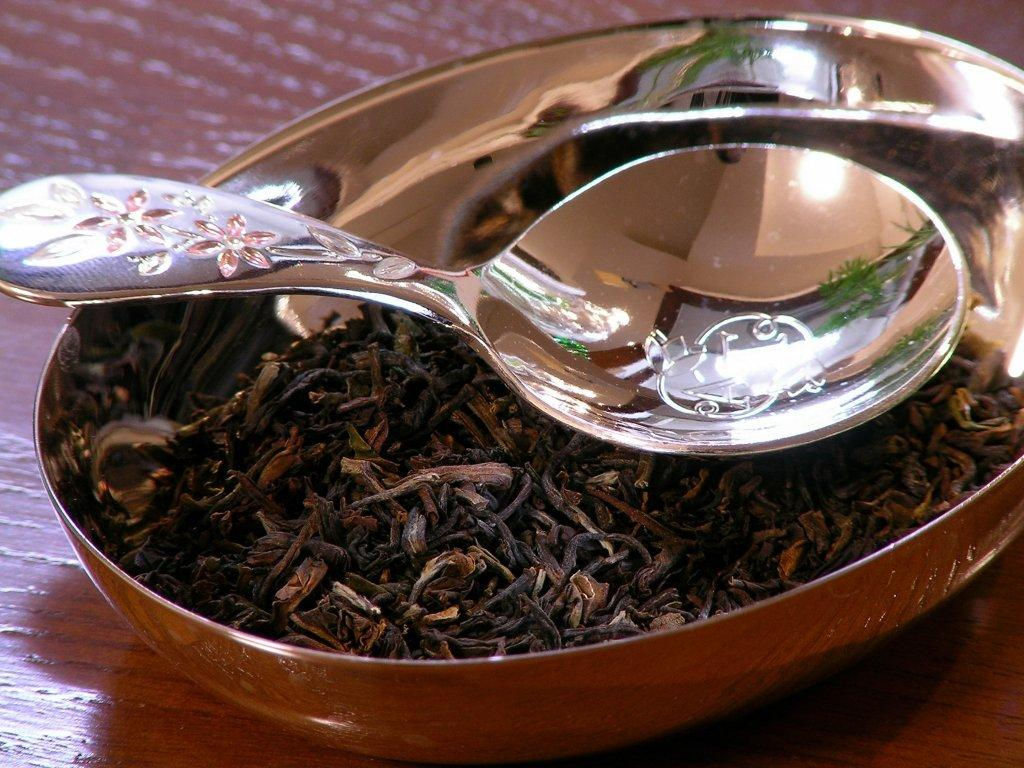What is in the bowl that is visible in the image? There is food in a bowl in the image. What utensil is used to eat the food in the bowl? There is a spoon in the bowl. What material is the floor made of in the image? The floor appears to be made of wood. What can be seen in the spoon's reflection? There is a reflection of light on the spoon, and a door is visible in the reflection. What type of grass is growing in the crate in the image? There is no crate or grass present in the image. 